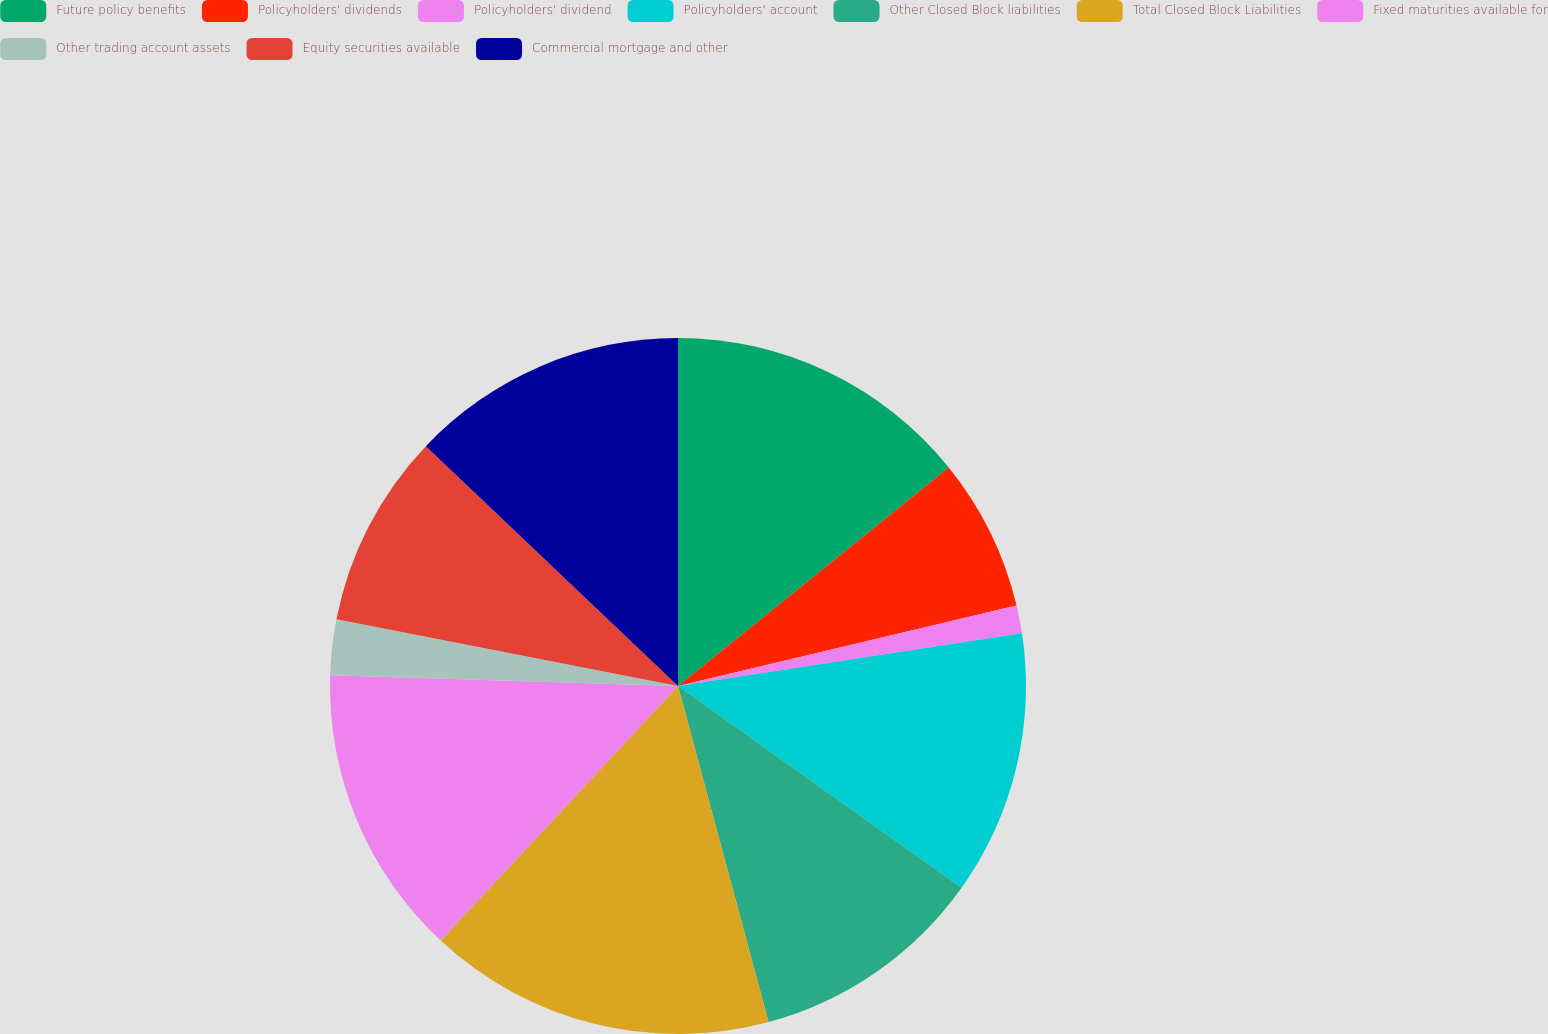Convert chart. <chart><loc_0><loc_0><loc_500><loc_500><pie_chart><fcel>Future policy benefits<fcel>Policyholders' dividends<fcel>Policyholders' dividend<fcel>Policyholders' account<fcel>Other Closed Block liabilities<fcel>Total Closed Block Liabilities<fcel>Fixed maturities available for<fcel>Other trading account assets<fcel>Equity securities available<fcel>Commercial mortgage and other<nl><fcel>14.19%<fcel>7.1%<fcel>1.29%<fcel>12.26%<fcel>10.97%<fcel>16.13%<fcel>13.55%<fcel>2.58%<fcel>9.03%<fcel>12.9%<nl></chart> 